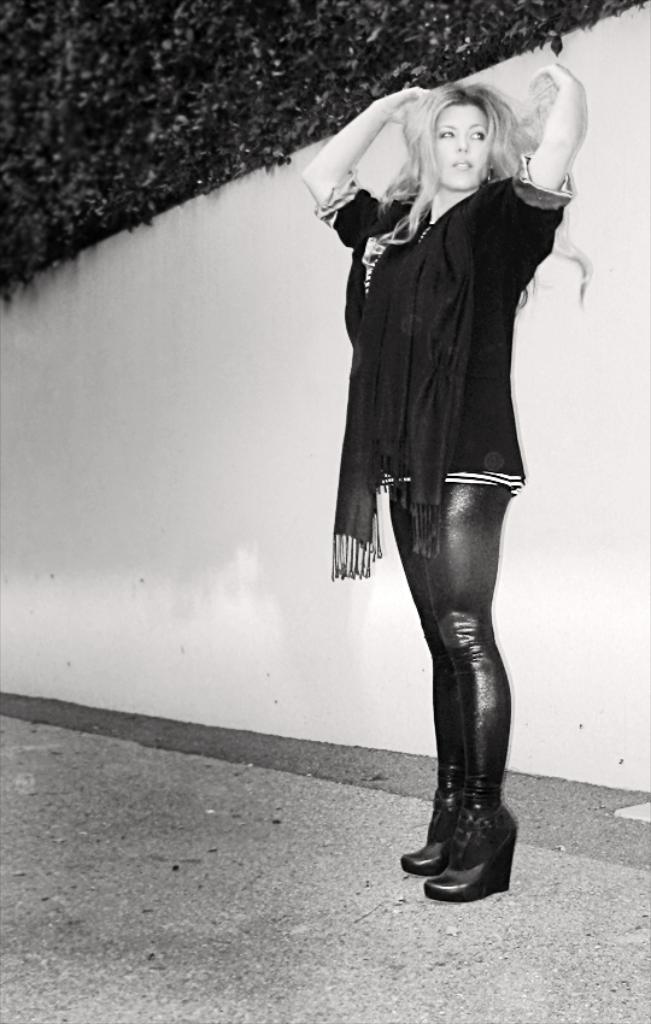How would you summarize this image in a sentence or two? This is a black and white image. Here I can see a woman wearing a black color dress, standing on the floor and looking at the right side. At the back of her there is a wall. On the top of the image I can see the leaves of a tree. 